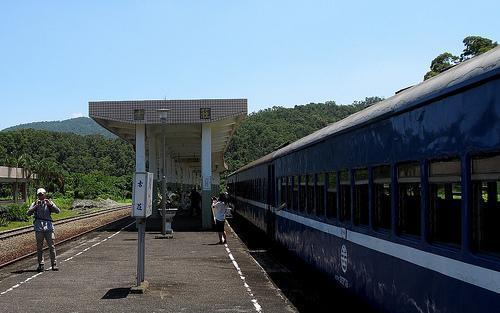How many people are in the photo?
Give a very brief answer. 2. 